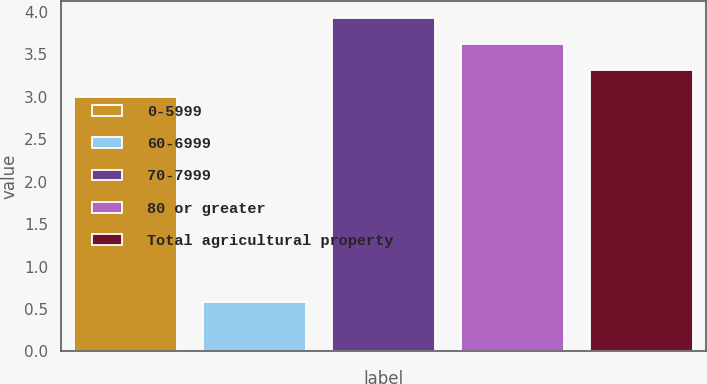Convert chart to OTSL. <chart><loc_0><loc_0><loc_500><loc_500><bar_chart><fcel>0-5999<fcel>60-6999<fcel>70-7999<fcel>80 or greater<fcel>Total agricultural property<nl><fcel>3<fcel>0.58<fcel>3.93<fcel>3.62<fcel>3.31<nl></chart> 